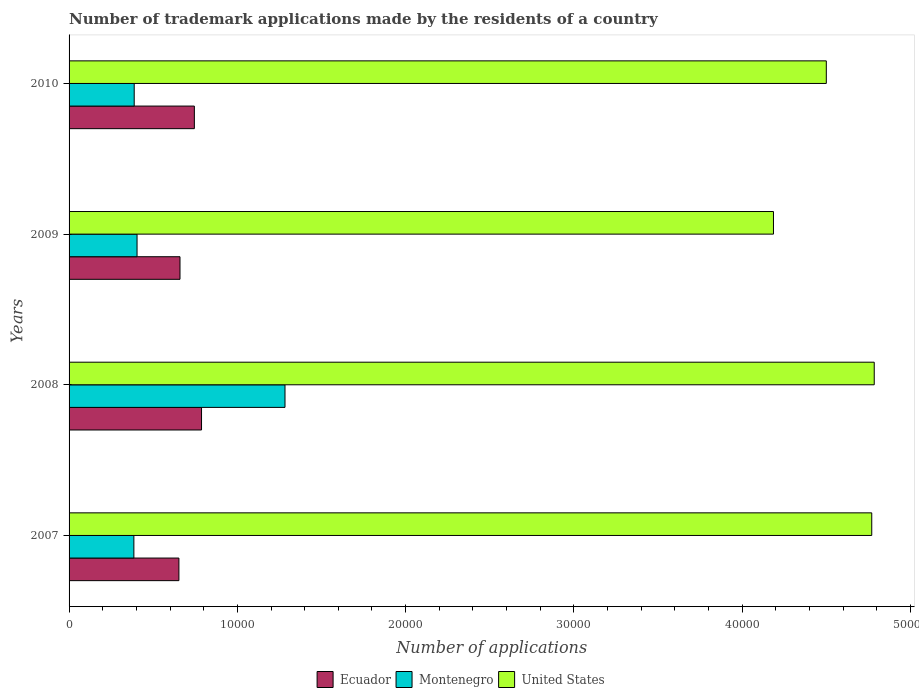How many groups of bars are there?
Your response must be concise. 4. Are the number of bars on each tick of the Y-axis equal?
Ensure brevity in your answer.  Yes. How many bars are there on the 1st tick from the top?
Your answer should be compact. 3. What is the label of the 2nd group of bars from the top?
Give a very brief answer. 2009. In how many cases, is the number of bars for a given year not equal to the number of legend labels?
Provide a succinct answer. 0. What is the number of trademark applications made by the residents in United States in 2008?
Your answer should be compact. 4.78e+04. Across all years, what is the maximum number of trademark applications made by the residents in Ecuador?
Make the answer very short. 7872. Across all years, what is the minimum number of trademark applications made by the residents in United States?
Give a very brief answer. 4.19e+04. In which year was the number of trademark applications made by the residents in United States maximum?
Your answer should be very brief. 2008. What is the total number of trademark applications made by the residents in Ecuador in the graph?
Give a very brief answer. 2.84e+04. What is the difference between the number of trademark applications made by the residents in Ecuador in 2007 and that in 2008?
Offer a terse response. -1345. What is the difference between the number of trademark applications made by the residents in Montenegro in 2009 and the number of trademark applications made by the residents in Ecuador in 2007?
Make the answer very short. -2487. What is the average number of trademark applications made by the residents in Montenegro per year?
Provide a succinct answer. 6148.5. In the year 2010, what is the difference between the number of trademark applications made by the residents in United States and number of trademark applications made by the residents in Ecuador?
Give a very brief answer. 3.76e+04. In how many years, is the number of trademark applications made by the residents in Ecuador greater than 10000 ?
Give a very brief answer. 0. What is the ratio of the number of trademark applications made by the residents in Ecuador in 2007 to that in 2009?
Provide a succinct answer. 0.99. Is the number of trademark applications made by the residents in United States in 2008 less than that in 2009?
Make the answer very short. No. Is the difference between the number of trademark applications made by the residents in United States in 2007 and 2008 greater than the difference between the number of trademark applications made by the residents in Ecuador in 2007 and 2008?
Keep it short and to the point. Yes. What is the difference between the highest and the second highest number of trademark applications made by the residents in United States?
Ensure brevity in your answer.  148. What is the difference between the highest and the lowest number of trademark applications made by the residents in United States?
Your answer should be very brief. 5988. What does the 3rd bar from the top in 2009 represents?
Your answer should be very brief. Ecuador. What does the 2nd bar from the bottom in 2007 represents?
Offer a terse response. Montenegro. Is it the case that in every year, the sum of the number of trademark applications made by the residents in Ecuador and number of trademark applications made by the residents in Montenegro is greater than the number of trademark applications made by the residents in United States?
Keep it short and to the point. No. How many bars are there?
Provide a short and direct response. 12. Are all the bars in the graph horizontal?
Your answer should be very brief. Yes. Where does the legend appear in the graph?
Your response must be concise. Bottom center. How many legend labels are there?
Keep it short and to the point. 3. What is the title of the graph?
Make the answer very short. Number of trademark applications made by the residents of a country. Does "Micronesia" appear as one of the legend labels in the graph?
Your answer should be compact. No. What is the label or title of the X-axis?
Your response must be concise. Number of applications. What is the Number of applications of Ecuador in 2007?
Make the answer very short. 6527. What is the Number of applications of Montenegro in 2007?
Offer a very short reply. 3851. What is the Number of applications in United States in 2007?
Offer a very short reply. 4.77e+04. What is the Number of applications in Ecuador in 2008?
Provide a short and direct response. 7872. What is the Number of applications of Montenegro in 2008?
Make the answer very short. 1.28e+04. What is the Number of applications in United States in 2008?
Offer a very short reply. 4.78e+04. What is the Number of applications of Ecuador in 2009?
Ensure brevity in your answer.  6592. What is the Number of applications in Montenegro in 2009?
Keep it short and to the point. 4040. What is the Number of applications in United States in 2009?
Give a very brief answer. 4.19e+04. What is the Number of applications in Ecuador in 2010?
Make the answer very short. 7445. What is the Number of applications in Montenegro in 2010?
Keep it short and to the point. 3871. What is the Number of applications of United States in 2010?
Your answer should be compact. 4.50e+04. Across all years, what is the maximum Number of applications of Ecuador?
Provide a succinct answer. 7872. Across all years, what is the maximum Number of applications of Montenegro?
Make the answer very short. 1.28e+04. Across all years, what is the maximum Number of applications of United States?
Ensure brevity in your answer.  4.78e+04. Across all years, what is the minimum Number of applications of Ecuador?
Give a very brief answer. 6527. Across all years, what is the minimum Number of applications of Montenegro?
Keep it short and to the point. 3851. Across all years, what is the minimum Number of applications in United States?
Your answer should be very brief. 4.19e+04. What is the total Number of applications of Ecuador in the graph?
Make the answer very short. 2.84e+04. What is the total Number of applications of Montenegro in the graph?
Provide a short and direct response. 2.46e+04. What is the total Number of applications in United States in the graph?
Provide a short and direct response. 1.82e+05. What is the difference between the Number of applications of Ecuador in 2007 and that in 2008?
Your answer should be very brief. -1345. What is the difference between the Number of applications in Montenegro in 2007 and that in 2008?
Your answer should be very brief. -8981. What is the difference between the Number of applications in United States in 2007 and that in 2008?
Make the answer very short. -148. What is the difference between the Number of applications of Ecuador in 2007 and that in 2009?
Offer a terse response. -65. What is the difference between the Number of applications of Montenegro in 2007 and that in 2009?
Offer a very short reply. -189. What is the difference between the Number of applications in United States in 2007 and that in 2009?
Give a very brief answer. 5840. What is the difference between the Number of applications in Ecuador in 2007 and that in 2010?
Your answer should be compact. -918. What is the difference between the Number of applications of Montenegro in 2007 and that in 2010?
Keep it short and to the point. -20. What is the difference between the Number of applications of United States in 2007 and that in 2010?
Ensure brevity in your answer.  2700. What is the difference between the Number of applications in Ecuador in 2008 and that in 2009?
Ensure brevity in your answer.  1280. What is the difference between the Number of applications in Montenegro in 2008 and that in 2009?
Ensure brevity in your answer.  8792. What is the difference between the Number of applications of United States in 2008 and that in 2009?
Ensure brevity in your answer.  5988. What is the difference between the Number of applications in Ecuador in 2008 and that in 2010?
Offer a very short reply. 427. What is the difference between the Number of applications in Montenegro in 2008 and that in 2010?
Offer a very short reply. 8961. What is the difference between the Number of applications in United States in 2008 and that in 2010?
Make the answer very short. 2848. What is the difference between the Number of applications in Ecuador in 2009 and that in 2010?
Offer a terse response. -853. What is the difference between the Number of applications of Montenegro in 2009 and that in 2010?
Keep it short and to the point. 169. What is the difference between the Number of applications in United States in 2009 and that in 2010?
Provide a short and direct response. -3140. What is the difference between the Number of applications in Ecuador in 2007 and the Number of applications in Montenegro in 2008?
Your response must be concise. -6305. What is the difference between the Number of applications of Ecuador in 2007 and the Number of applications of United States in 2008?
Give a very brief answer. -4.13e+04. What is the difference between the Number of applications in Montenegro in 2007 and the Number of applications in United States in 2008?
Provide a short and direct response. -4.40e+04. What is the difference between the Number of applications in Ecuador in 2007 and the Number of applications in Montenegro in 2009?
Your response must be concise. 2487. What is the difference between the Number of applications in Ecuador in 2007 and the Number of applications in United States in 2009?
Make the answer very short. -3.53e+04. What is the difference between the Number of applications in Montenegro in 2007 and the Number of applications in United States in 2009?
Provide a short and direct response. -3.80e+04. What is the difference between the Number of applications of Ecuador in 2007 and the Number of applications of Montenegro in 2010?
Your answer should be very brief. 2656. What is the difference between the Number of applications in Ecuador in 2007 and the Number of applications in United States in 2010?
Make the answer very short. -3.85e+04. What is the difference between the Number of applications in Montenegro in 2007 and the Number of applications in United States in 2010?
Keep it short and to the point. -4.11e+04. What is the difference between the Number of applications of Ecuador in 2008 and the Number of applications of Montenegro in 2009?
Provide a succinct answer. 3832. What is the difference between the Number of applications of Ecuador in 2008 and the Number of applications of United States in 2009?
Keep it short and to the point. -3.40e+04. What is the difference between the Number of applications of Montenegro in 2008 and the Number of applications of United States in 2009?
Offer a very short reply. -2.90e+04. What is the difference between the Number of applications in Ecuador in 2008 and the Number of applications in Montenegro in 2010?
Provide a short and direct response. 4001. What is the difference between the Number of applications of Ecuador in 2008 and the Number of applications of United States in 2010?
Offer a very short reply. -3.71e+04. What is the difference between the Number of applications of Montenegro in 2008 and the Number of applications of United States in 2010?
Keep it short and to the point. -3.22e+04. What is the difference between the Number of applications of Ecuador in 2009 and the Number of applications of Montenegro in 2010?
Make the answer very short. 2721. What is the difference between the Number of applications in Ecuador in 2009 and the Number of applications in United States in 2010?
Your answer should be compact. -3.84e+04. What is the difference between the Number of applications of Montenegro in 2009 and the Number of applications of United States in 2010?
Give a very brief answer. -4.10e+04. What is the average Number of applications in Ecuador per year?
Give a very brief answer. 7109. What is the average Number of applications in Montenegro per year?
Give a very brief answer. 6148.5. What is the average Number of applications of United States per year?
Keep it short and to the point. 4.56e+04. In the year 2007, what is the difference between the Number of applications of Ecuador and Number of applications of Montenegro?
Provide a succinct answer. 2676. In the year 2007, what is the difference between the Number of applications of Ecuador and Number of applications of United States?
Your answer should be compact. -4.12e+04. In the year 2007, what is the difference between the Number of applications in Montenegro and Number of applications in United States?
Provide a succinct answer. -4.38e+04. In the year 2008, what is the difference between the Number of applications in Ecuador and Number of applications in Montenegro?
Ensure brevity in your answer.  -4960. In the year 2008, what is the difference between the Number of applications of Ecuador and Number of applications of United States?
Offer a terse response. -4.00e+04. In the year 2008, what is the difference between the Number of applications of Montenegro and Number of applications of United States?
Your response must be concise. -3.50e+04. In the year 2009, what is the difference between the Number of applications in Ecuador and Number of applications in Montenegro?
Keep it short and to the point. 2552. In the year 2009, what is the difference between the Number of applications in Ecuador and Number of applications in United States?
Offer a very short reply. -3.53e+04. In the year 2009, what is the difference between the Number of applications of Montenegro and Number of applications of United States?
Your answer should be compact. -3.78e+04. In the year 2010, what is the difference between the Number of applications in Ecuador and Number of applications in Montenegro?
Ensure brevity in your answer.  3574. In the year 2010, what is the difference between the Number of applications in Ecuador and Number of applications in United States?
Offer a very short reply. -3.76e+04. In the year 2010, what is the difference between the Number of applications in Montenegro and Number of applications in United States?
Provide a succinct answer. -4.11e+04. What is the ratio of the Number of applications in Ecuador in 2007 to that in 2008?
Keep it short and to the point. 0.83. What is the ratio of the Number of applications in Montenegro in 2007 to that in 2008?
Provide a short and direct response. 0.3. What is the ratio of the Number of applications of United States in 2007 to that in 2008?
Give a very brief answer. 1. What is the ratio of the Number of applications of Montenegro in 2007 to that in 2009?
Your response must be concise. 0.95. What is the ratio of the Number of applications of United States in 2007 to that in 2009?
Make the answer very short. 1.14. What is the ratio of the Number of applications of Ecuador in 2007 to that in 2010?
Ensure brevity in your answer.  0.88. What is the ratio of the Number of applications of United States in 2007 to that in 2010?
Give a very brief answer. 1.06. What is the ratio of the Number of applications in Ecuador in 2008 to that in 2009?
Provide a succinct answer. 1.19. What is the ratio of the Number of applications in Montenegro in 2008 to that in 2009?
Keep it short and to the point. 3.18. What is the ratio of the Number of applications in United States in 2008 to that in 2009?
Offer a very short reply. 1.14. What is the ratio of the Number of applications in Ecuador in 2008 to that in 2010?
Ensure brevity in your answer.  1.06. What is the ratio of the Number of applications of Montenegro in 2008 to that in 2010?
Your answer should be compact. 3.31. What is the ratio of the Number of applications of United States in 2008 to that in 2010?
Your answer should be compact. 1.06. What is the ratio of the Number of applications in Ecuador in 2009 to that in 2010?
Ensure brevity in your answer.  0.89. What is the ratio of the Number of applications of Montenegro in 2009 to that in 2010?
Offer a very short reply. 1.04. What is the ratio of the Number of applications in United States in 2009 to that in 2010?
Provide a short and direct response. 0.93. What is the difference between the highest and the second highest Number of applications of Ecuador?
Provide a short and direct response. 427. What is the difference between the highest and the second highest Number of applications of Montenegro?
Provide a succinct answer. 8792. What is the difference between the highest and the second highest Number of applications in United States?
Ensure brevity in your answer.  148. What is the difference between the highest and the lowest Number of applications in Ecuador?
Provide a succinct answer. 1345. What is the difference between the highest and the lowest Number of applications in Montenegro?
Your answer should be compact. 8981. What is the difference between the highest and the lowest Number of applications of United States?
Offer a very short reply. 5988. 